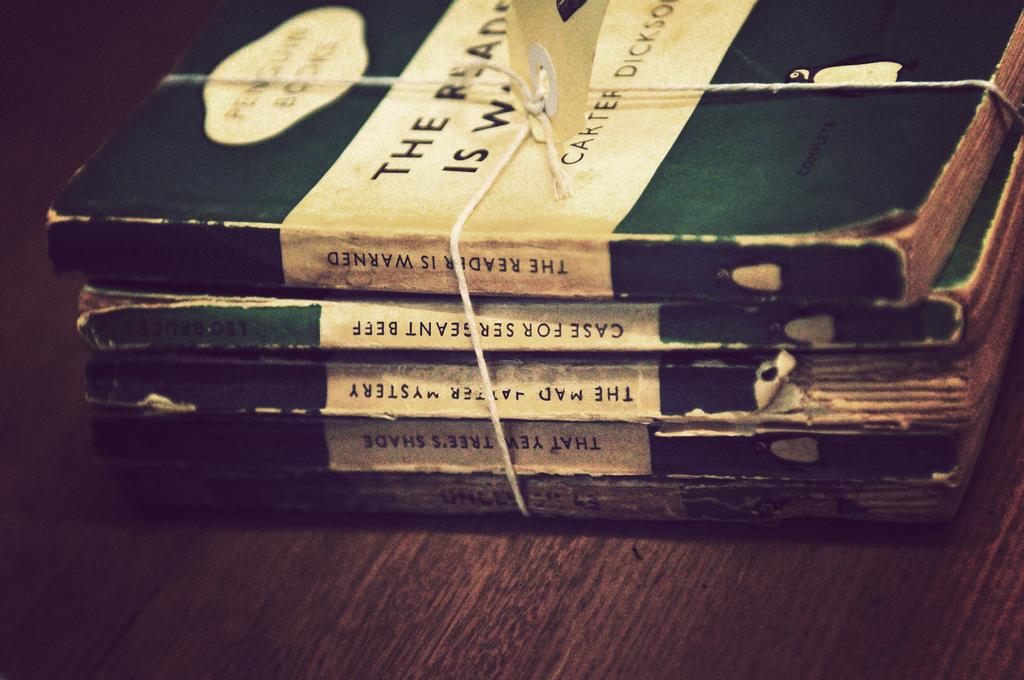<image>
Render a clear and concise summary of the photo. a collection of books by carter that says the reader warned 